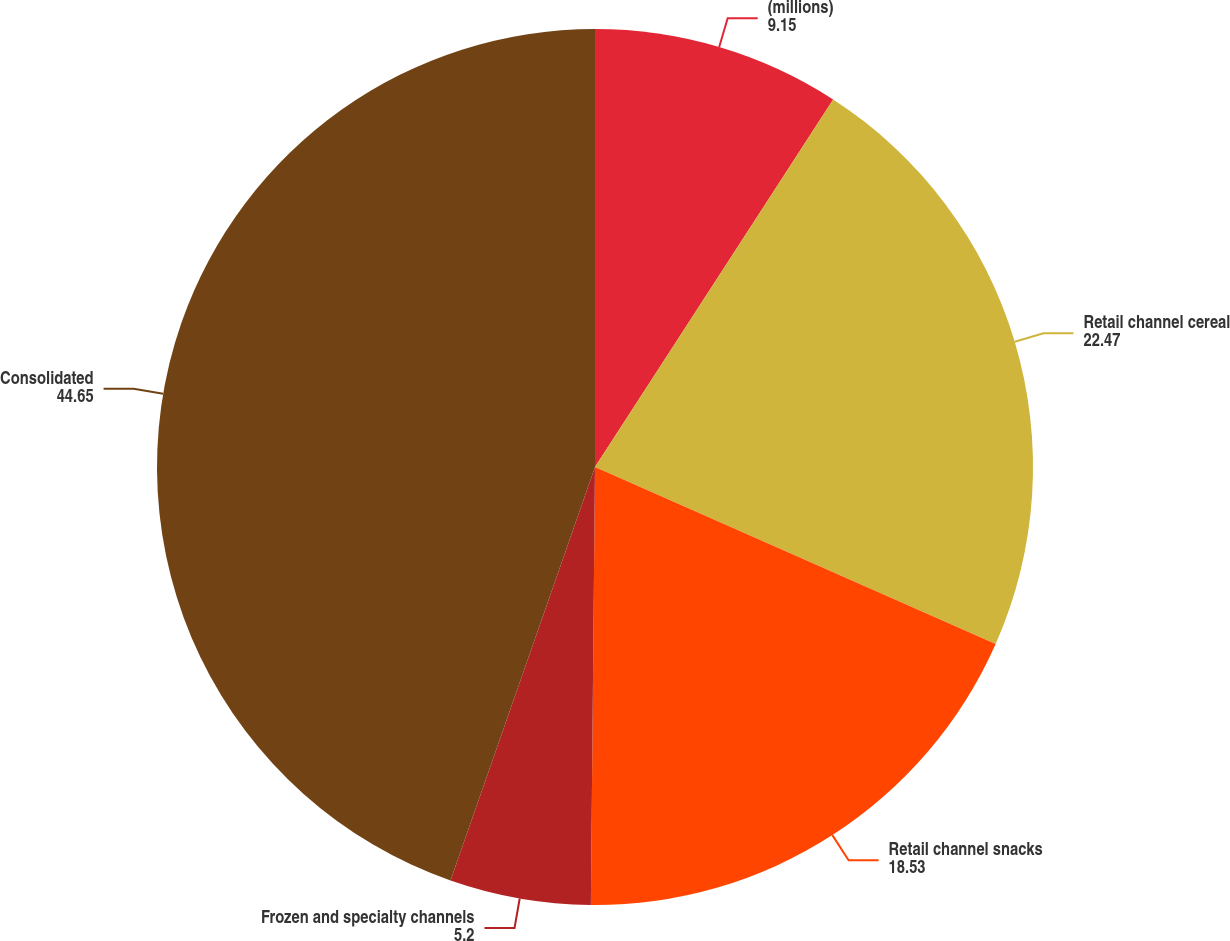<chart> <loc_0><loc_0><loc_500><loc_500><pie_chart><fcel>(millions)<fcel>Retail channel cereal<fcel>Retail channel snacks<fcel>Frozen and specialty channels<fcel>Consolidated<nl><fcel>9.15%<fcel>22.47%<fcel>18.53%<fcel>5.2%<fcel>44.65%<nl></chart> 